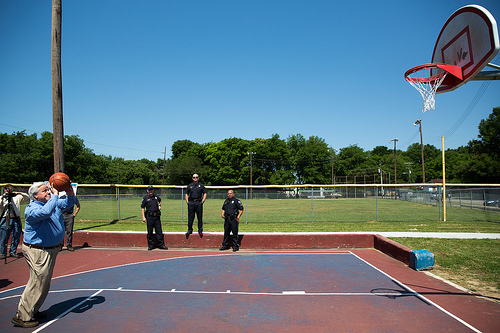<image>
Is the sky behind the tree? Yes. From this viewpoint, the sky is positioned behind the tree, with the tree partially or fully occluding the sky. 